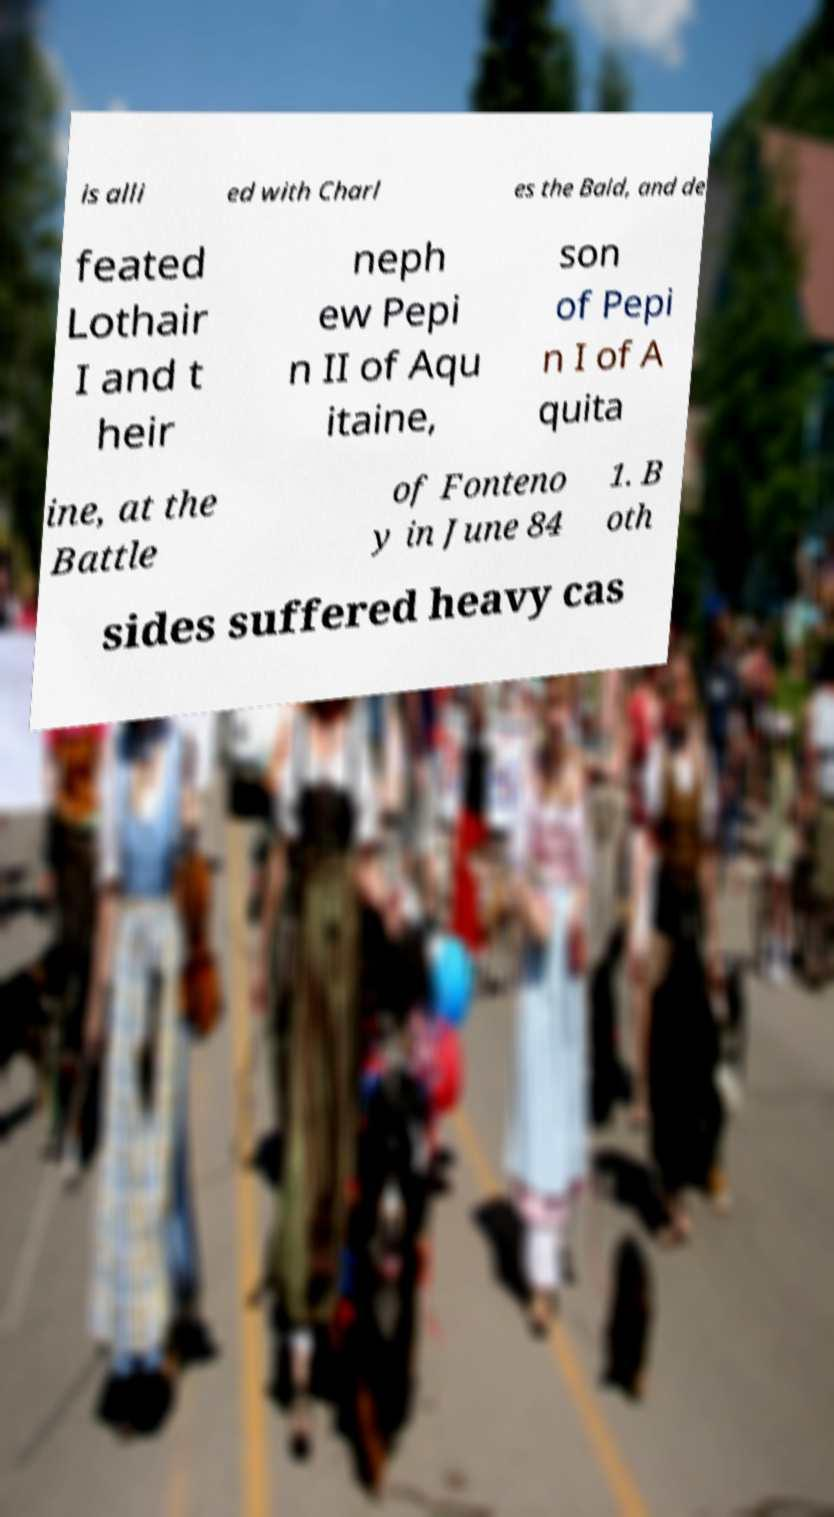Please read and relay the text visible in this image. What does it say? is alli ed with Charl es the Bald, and de feated Lothair I and t heir neph ew Pepi n II of Aqu itaine, son of Pepi n I of A quita ine, at the Battle of Fonteno y in June 84 1. B oth sides suffered heavy cas 